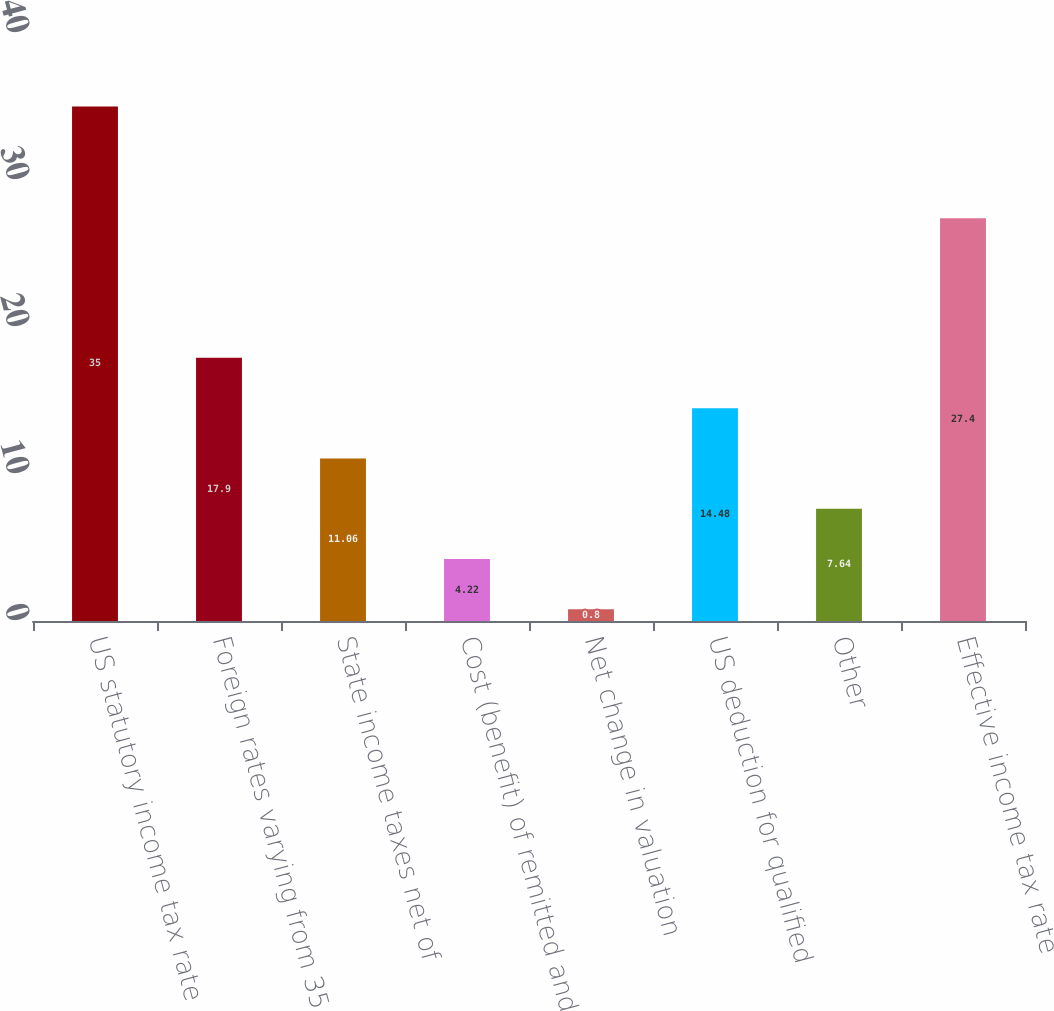Convert chart. <chart><loc_0><loc_0><loc_500><loc_500><bar_chart><fcel>US statutory income tax rate<fcel>Foreign rates varying from 35<fcel>State income taxes net of<fcel>Cost (benefit) of remitted and<fcel>Net change in valuation<fcel>US deduction for qualified<fcel>Other<fcel>Effective income tax rate<nl><fcel>35<fcel>17.9<fcel>11.06<fcel>4.22<fcel>0.8<fcel>14.48<fcel>7.64<fcel>27.4<nl></chart> 